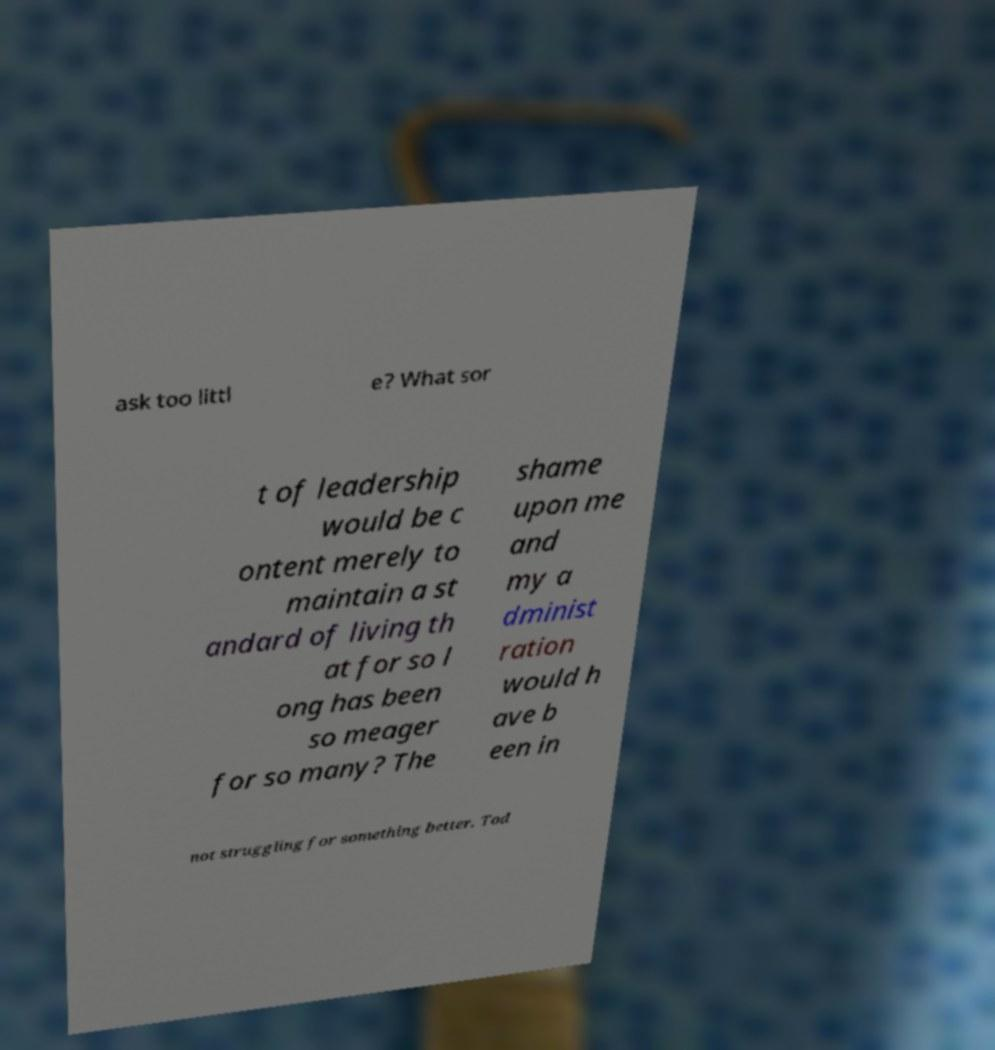I need the written content from this picture converted into text. Can you do that? ask too littl e? What sor t of leadership would be c ontent merely to maintain a st andard of living th at for so l ong has been so meager for so many? The shame upon me and my a dminist ration would h ave b een in not struggling for something better. Tod 